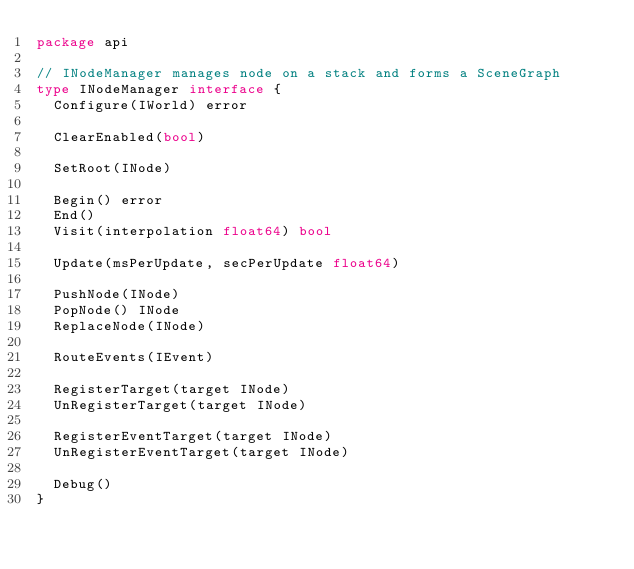Convert code to text. <code><loc_0><loc_0><loc_500><loc_500><_Go_>package api

// INodeManager manages node on a stack and forms a SceneGraph
type INodeManager interface {
	Configure(IWorld) error

	ClearEnabled(bool)

	SetRoot(INode)

	Begin() error
	End()
	Visit(interpolation float64) bool

	Update(msPerUpdate, secPerUpdate float64)

	PushNode(INode)
	PopNode() INode
	ReplaceNode(INode)

	RouteEvents(IEvent)

	RegisterTarget(target INode)
	UnRegisterTarget(target INode)

	RegisterEventTarget(target INode)
	UnRegisterEventTarget(target INode)

	Debug()
}
</code> 